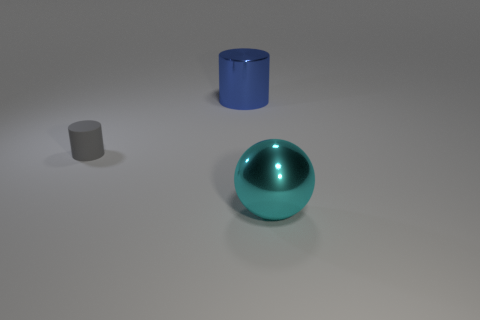Is the number of blue cylinders on the right side of the shiny cylinder less than the number of rubber things?
Provide a short and direct response. Yes. There is a large cyan shiny thing; what shape is it?
Give a very brief answer. Sphere. What size is the thing behind the rubber thing?
Make the answer very short. Large. What color is the other metallic object that is the same size as the blue object?
Offer a very short reply. Cyan. Are there any big cylinders that have the same color as the small cylinder?
Your answer should be compact. No. Are there fewer metallic cylinders behind the large shiny cylinder than objects in front of the large metallic ball?
Your answer should be very brief. No. There is a object that is on the right side of the tiny thing and behind the cyan sphere; what is its material?
Your answer should be compact. Metal. There is a small rubber object; is it the same shape as the large metal object behind the gray cylinder?
Provide a short and direct response. Yes. How many other objects are the same size as the gray rubber cylinder?
Your answer should be compact. 0. Is the number of cyan things greater than the number of cylinders?
Provide a succinct answer. No. 